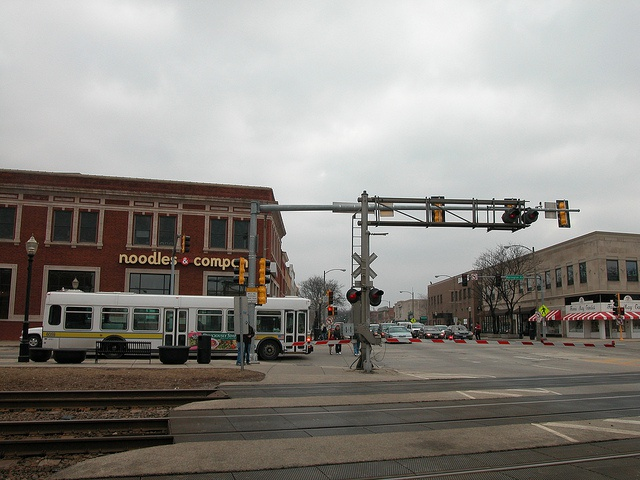Describe the objects in this image and their specific colors. I can see bus in lightgray, black, darkgray, gray, and olive tones, traffic light in lightgray, black, gray, and maroon tones, traffic light in lightgray, black, brown, gray, and darkgray tones, traffic light in lightgray, black, gray, brown, and maroon tones, and car in lightgray, gray, black, and maroon tones in this image. 